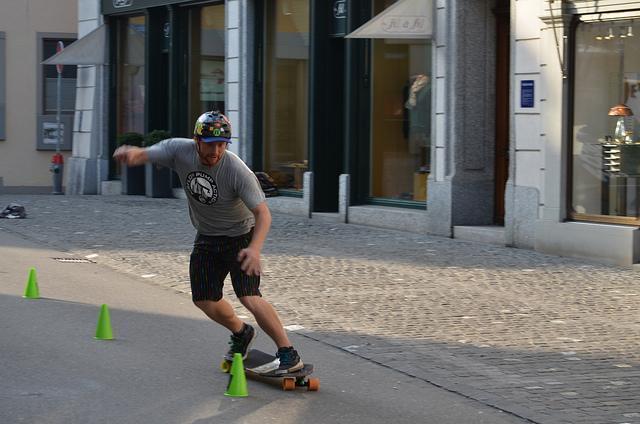How many horses are on the beach?
Give a very brief answer. 0. 